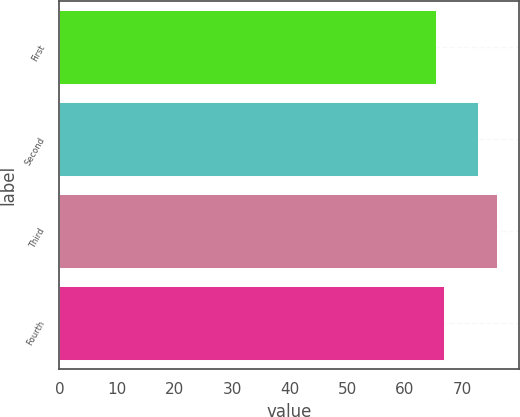<chart> <loc_0><loc_0><loc_500><loc_500><bar_chart><fcel>First<fcel>Second<fcel>Third<fcel>Fourth<nl><fcel>65.38<fcel>72.67<fcel>75.99<fcel>66.71<nl></chart> 